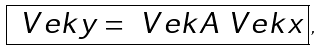<formula> <loc_0><loc_0><loc_500><loc_500>\boxed { \ V e k { y } = \ V e k { A } \ V e k { x } } \, ,</formula> 